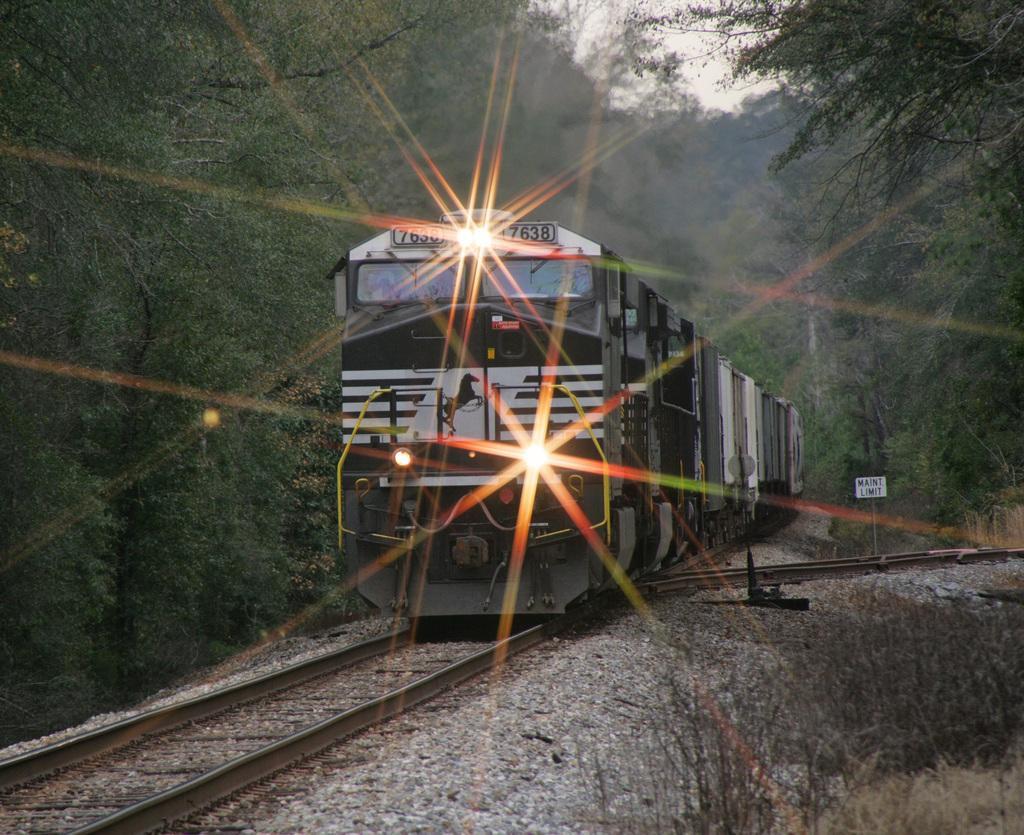Describe this image in one or two sentences. On the left side, there is a train having three lights, on the railway track. On both sides of this railway track, there are trees. On the right side, there is a signboard. Beside this signboard, there is another railway track. In the background, there are trees and there is sky. 